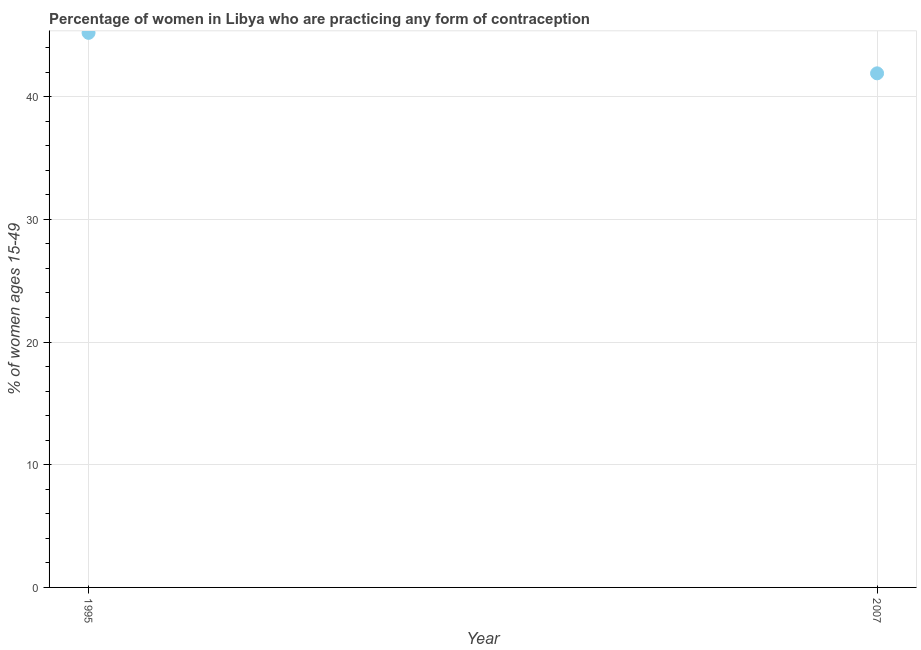What is the contraceptive prevalence in 1995?
Make the answer very short. 45.2. Across all years, what is the maximum contraceptive prevalence?
Make the answer very short. 45.2. Across all years, what is the minimum contraceptive prevalence?
Your answer should be compact. 41.9. In which year was the contraceptive prevalence maximum?
Give a very brief answer. 1995. In which year was the contraceptive prevalence minimum?
Provide a succinct answer. 2007. What is the sum of the contraceptive prevalence?
Give a very brief answer. 87.1. What is the difference between the contraceptive prevalence in 1995 and 2007?
Provide a succinct answer. 3.3. What is the average contraceptive prevalence per year?
Ensure brevity in your answer.  43.55. What is the median contraceptive prevalence?
Provide a succinct answer. 43.55. In how many years, is the contraceptive prevalence greater than 34 %?
Make the answer very short. 2. What is the ratio of the contraceptive prevalence in 1995 to that in 2007?
Offer a terse response. 1.08. Is the contraceptive prevalence in 1995 less than that in 2007?
Your answer should be very brief. No. How many dotlines are there?
Provide a short and direct response. 1. How many years are there in the graph?
Your answer should be very brief. 2. What is the difference between two consecutive major ticks on the Y-axis?
Give a very brief answer. 10. Are the values on the major ticks of Y-axis written in scientific E-notation?
Offer a very short reply. No. Does the graph contain any zero values?
Keep it short and to the point. No. What is the title of the graph?
Your answer should be very brief. Percentage of women in Libya who are practicing any form of contraception. What is the label or title of the Y-axis?
Provide a succinct answer. % of women ages 15-49. What is the % of women ages 15-49 in 1995?
Your response must be concise. 45.2. What is the % of women ages 15-49 in 2007?
Keep it short and to the point. 41.9. What is the difference between the % of women ages 15-49 in 1995 and 2007?
Offer a terse response. 3.3. What is the ratio of the % of women ages 15-49 in 1995 to that in 2007?
Provide a succinct answer. 1.08. 